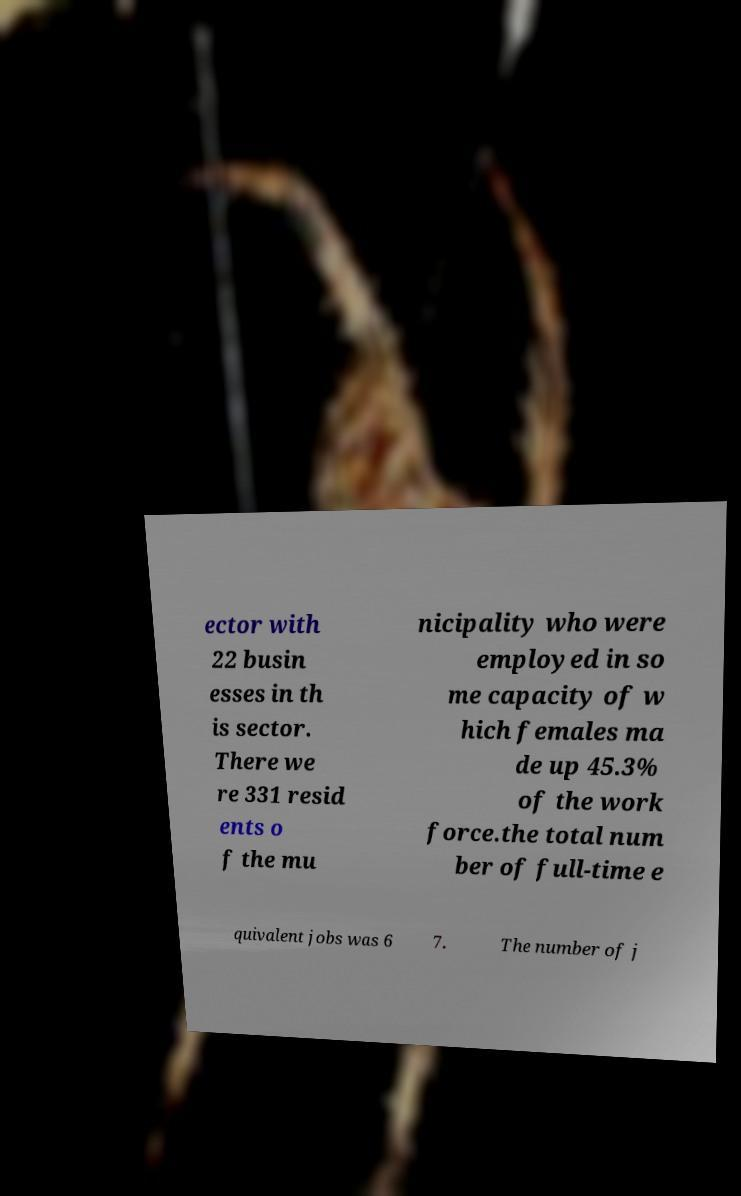Please identify and transcribe the text found in this image. ector with 22 busin esses in th is sector. There we re 331 resid ents o f the mu nicipality who were employed in so me capacity of w hich females ma de up 45.3% of the work force.the total num ber of full-time e quivalent jobs was 6 7. The number of j 